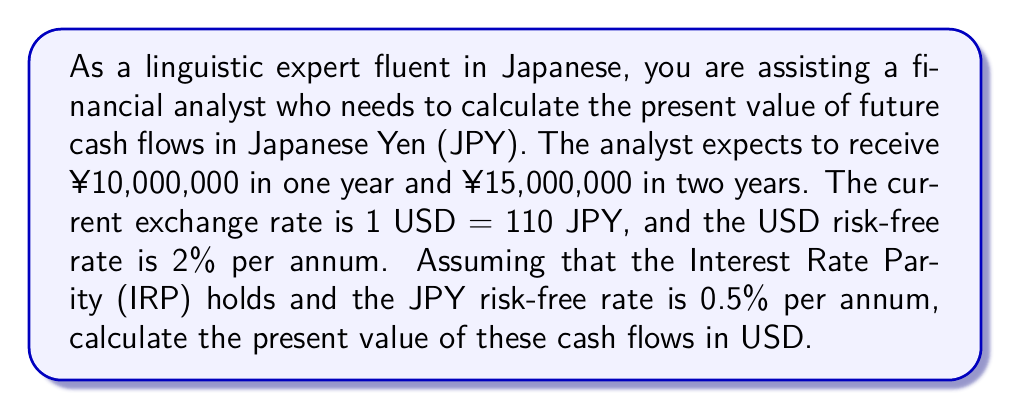Give your solution to this math problem. To solve this problem, we'll follow these steps:

1) First, we need to calculate the forward exchange rates for year 1 and year 2 using the Interest Rate Parity (IRP) formula:

   $$F_t = S_0 \cdot \frac{(1 + r_{USD})^t}{(1 + r_{JPY})^t}$$

   Where:
   $F_t$ is the forward exchange rate at time $t$
   $S_0$ is the spot exchange rate
   $r_{USD}$ is the USD risk-free rate
   $r_{JPY}$ is the JPY risk-free rate
   $t$ is the time in years

2) Calculate the forward rates:

   For Year 1: $$F_1 = 110 \cdot \frac{(1 + 0.02)^1}{(1 + 0.005)^1} = 111.65$$

   For Year 2: $$F_2 = 110 \cdot \frac{(1 + 0.02)^2}{(1 + 0.005)^2} = 113.32$$

3) Now, convert the future JPY cash flows to USD using these forward rates:

   Year 1: ¥10,000,000 / 111.65 = $89,565.61
   Year 2: ¥15,000,000 / 113.32 = $132,367.63

4) Finally, calculate the present value of these USD cash flows using the USD risk-free rate:

   $$PV = \frac{CF_1}{(1 + r_{USD})^1} + \frac{CF_2}{(1 + r_{USD})^2}$$

   $$PV = \frac{89,565.61}{(1 + 0.02)^1} + \frac{132,367.63}{(1 + 0.02)^2}$$

   $$PV = 87,809.42 + 127,235.76 = 215,045.18$$

Therefore, the present value of the future JPY cash flows is $215,045.18 USD.
Answer: $215,045.18 USD 